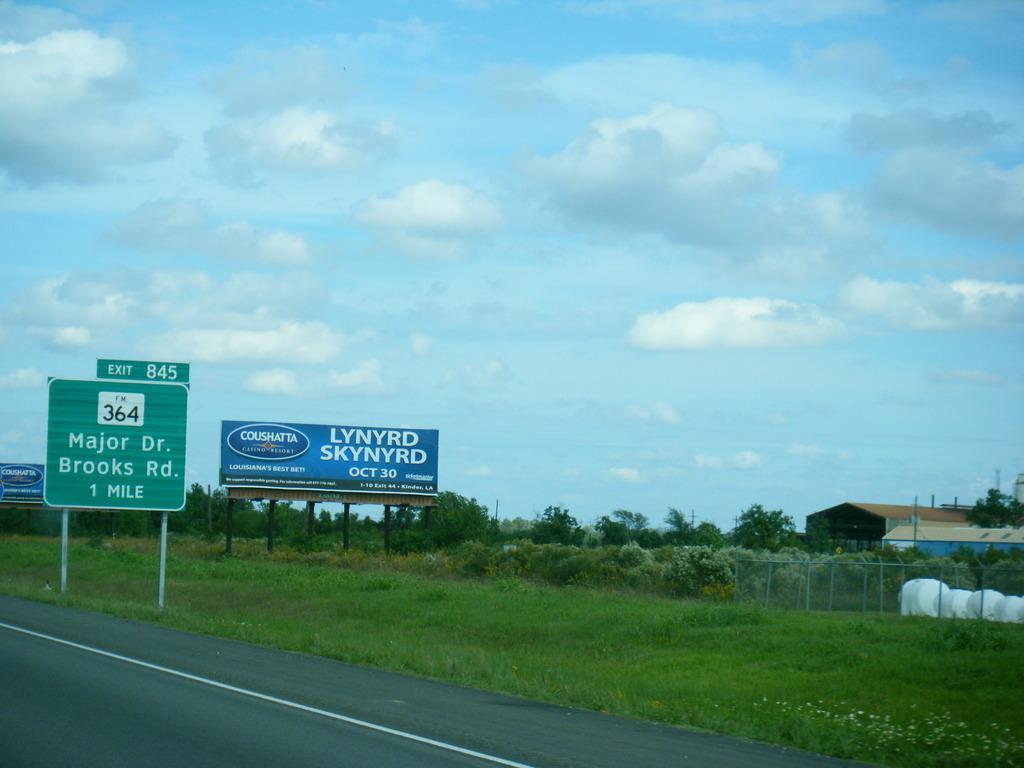Please provide a concise description of this image. In this image, we can see boards beside the road. There is a fencing and shed on the right side of the image. There are some trees in the middle of the image. In the background of the image, there is a sky. 